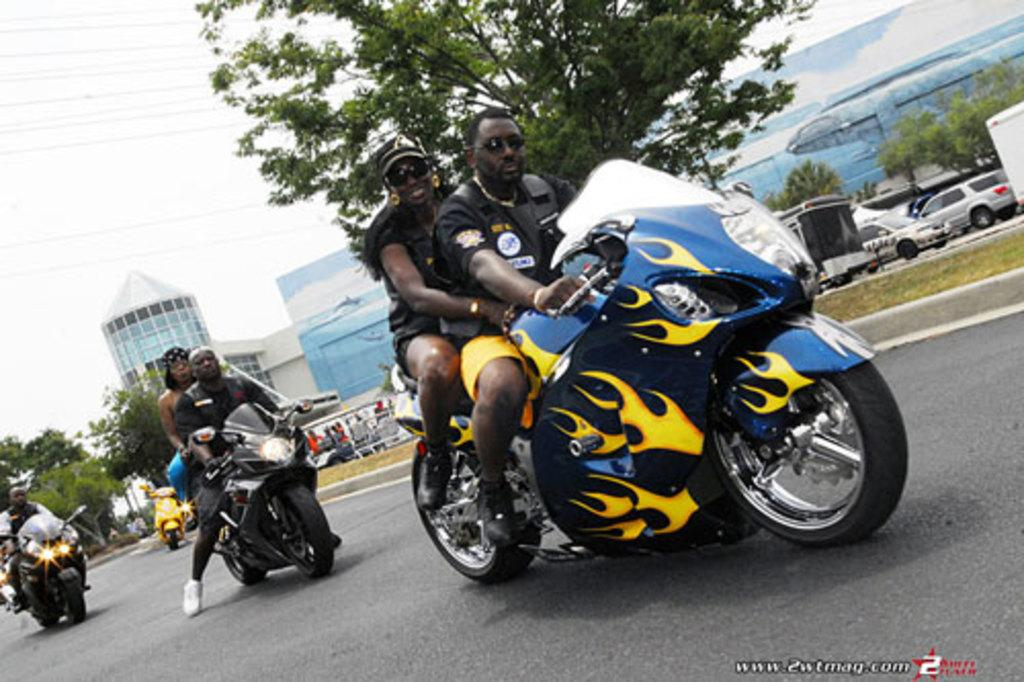What is the color of the road in the image? The road in the image is black. What type of vehicles are present in the image? There are bikes in the image. What are the people on the bikes doing? People are sitting on the bikes. What can be seen in the background of the image? There is a blue building in the background of the image. What type of vegetation is visible in the image? There is grass visible in the image. What grade is the toy in the image? There is no toy present in the image. What type of home is depicted in the image? The image does not show a home; it features a black road, bikes, people, a blue building, and grass. 